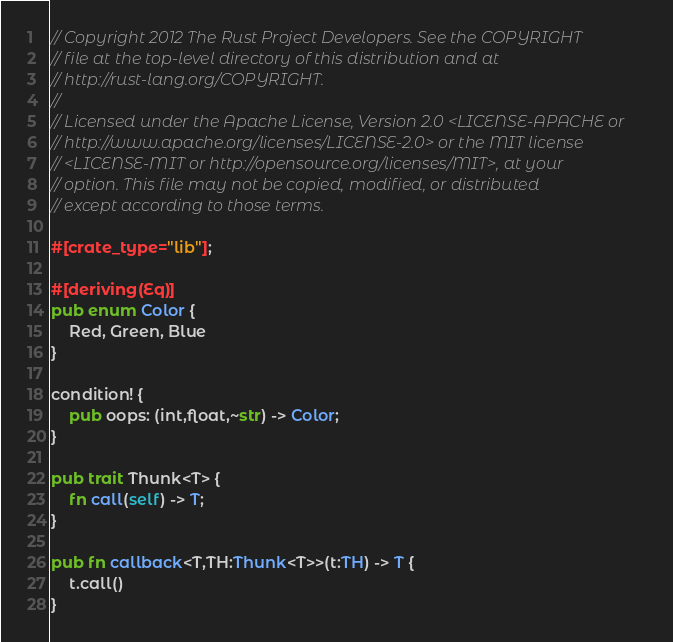Convert code to text. <code><loc_0><loc_0><loc_500><loc_500><_Rust_>// Copyright 2012 The Rust Project Developers. See the COPYRIGHT
// file at the top-level directory of this distribution and at
// http://rust-lang.org/COPYRIGHT.
//
// Licensed under the Apache License, Version 2.0 <LICENSE-APACHE or
// http://www.apache.org/licenses/LICENSE-2.0> or the MIT license
// <LICENSE-MIT or http://opensource.org/licenses/MIT>, at your
// option. This file may not be copied, modified, or distributed
// except according to those terms.

#[crate_type="lib"];

#[deriving(Eq)]
pub enum Color {
    Red, Green, Blue
}

condition! {
    pub oops: (int,float,~str) -> Color;
}

pub trait Thunk<T> {
    fn call(self) -> T;
}

pub fn callback<T,TH:Thunk<T>>(t:TH) -> T {
    t.call()
}
</code> 